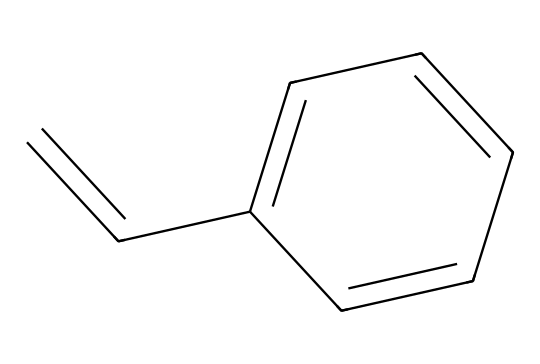What is the molecular formula of styrene? By analyzing the structure represented by the SMILES, we can count the carbon (C) and hydrogen (H) atoms. There are 8 carbon atoms and 8 hydrogen atoms in the structure. Therefore, the molecular formula is C8H8.
Answer: C8H8 How many double bonds are present in styrene? In the structure of styrene as represented in the SMILES, we can identify one double bond between two carbon atoms in the linear part (C=C) and one more in the cyclic part (C1=CC). So, there are two double bonds in total.
Answer: 2 Which type of compound is styrene classified as? Styrene is an aromatic compound due to the presence of a benzene ring in its structure, indicated by the cyclic arrangement of carbon atoms.
Answer: aromatic What functional group is present in styrene? The presence of the vinyl group (C=C) indicates that styrene contains an alkene functional group. The double bond signifies this classification.
Answer: alkene How many hydrogen atoms are attached to each carbon in the aromatic ring of styrene? In the aromatic ring of styrene, each of the four carbon atoms is attached to a single hydrogen atom, while the carbons participating in the double bonds do not have hydrogen atoms attached.
Answer: 4 What is the significance of styrene in food packaging? Styrene is significant in food packaging due to its properties of flexibility, strength, and resistance to impact, making it suitable for various disposable containers.
Answer: flexibility 